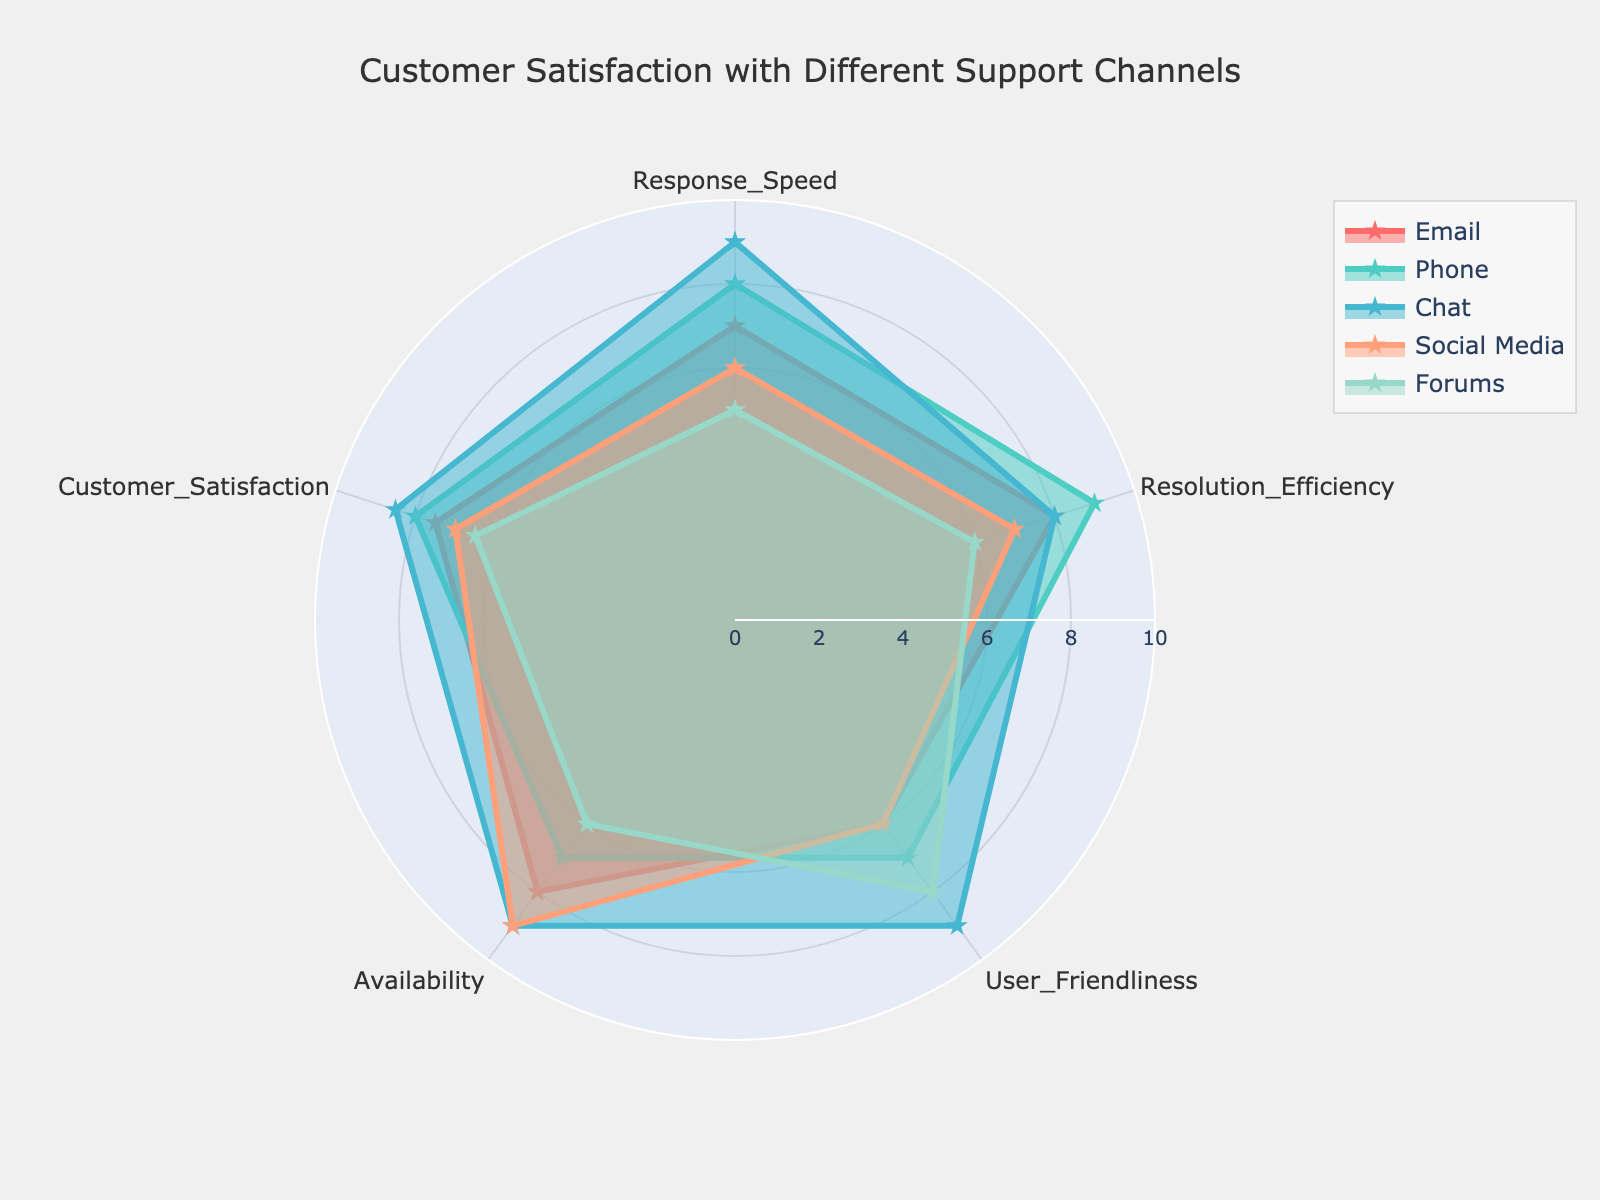What is the title of the radar chart? The title is usually displayed at the top of a chart. Here, you can see that the title of the radar chart is written as "Customer Satisfaction with Different Support Channels."
Answer: Customer Satisfaction with Different Support Channels How many support channels are compared in the radar chart? By examining the chart, we can see that there are five distinct lines, each representing a different support channel. These are Email, Phone, Chat, Social Media, and Forums.
Answer: 5 Which support channel has the highest 'User Friendliness'? Looking at the 'User Friendliness' axis, we can see that the Chat channel's value reaches 9, which is the highest compared to the other channels.
Answer: Chat What is the average 'Customer Satisfaction' score across all support channels? The scores for 'Customer Satisfaction' are Email: 7.5, Phone: 8, Chat: 8.5, Social Media: 7, Forums: 6.5. Adding them up gives us 37.5. Dividing by 5 channels, the average score is 37.5 / 5 = 7.5
Answer: 7.5 What is the difference in 'Availability' between Chat and Forums? Looking at the 'Availability' values, Chat has a score of 9 and Forums have a score of 6. The difference is 9 - 6 = 3.
Answer: 3 Which support channel scores the lowest in 'Response Speed'? The 'Response Speed' axis shows that Forums have the lowest value of 5 among all support channels.
Answer: Forums How does 'Resolution Efficiency' of Email compare to Phone? Email has a 'Resolution Efficiency' score of 8 and Phone has a score of 9. Thus, Phone has a higher 'Resolution Efficiency' than Email.
Answer: Phone What is the range of 'Resolution Efficiency' scores observed in the chart? The 'Resolution Efficiency' scores range from the lowest score of 6 (Forums) to the highest score of 9 (Phone). The range is 9 - 6 = 3.
Answer: 3 Which support channel has the most balanced performance across all five metrics? By looking at the radar chart, Chat appears to have the most balanced performance, with relatively high and similar scores across all five metrics: 9, 8, 9, 9, and 8.5.
Answer: Chat 